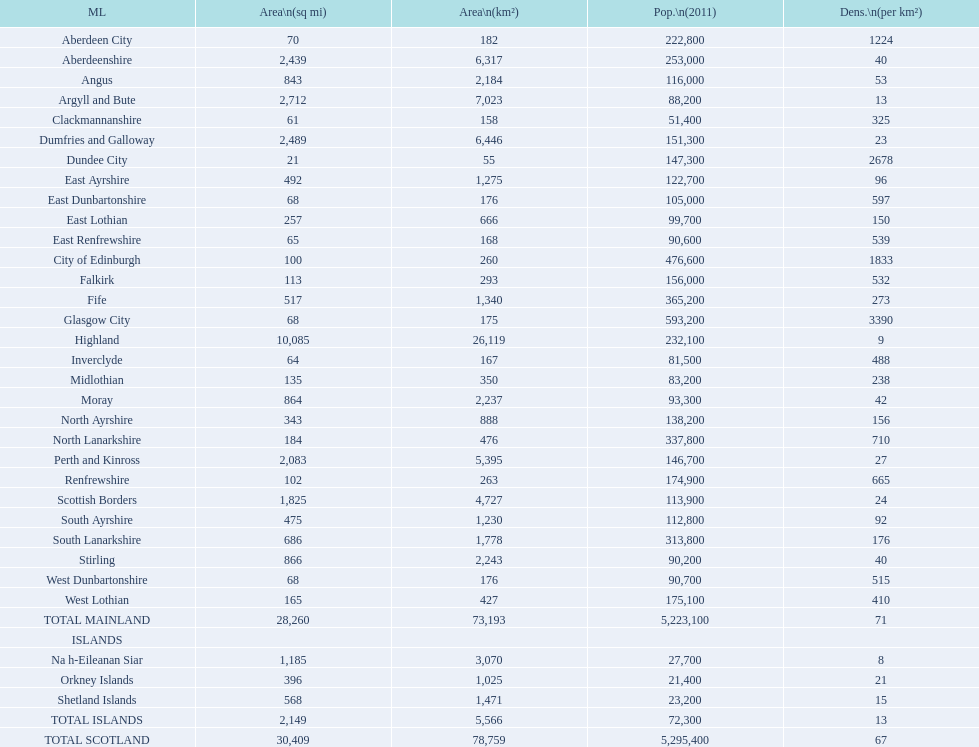If you were to arrange the locations from the smallest to largest area, which one would be first on the list? Dundee City. 